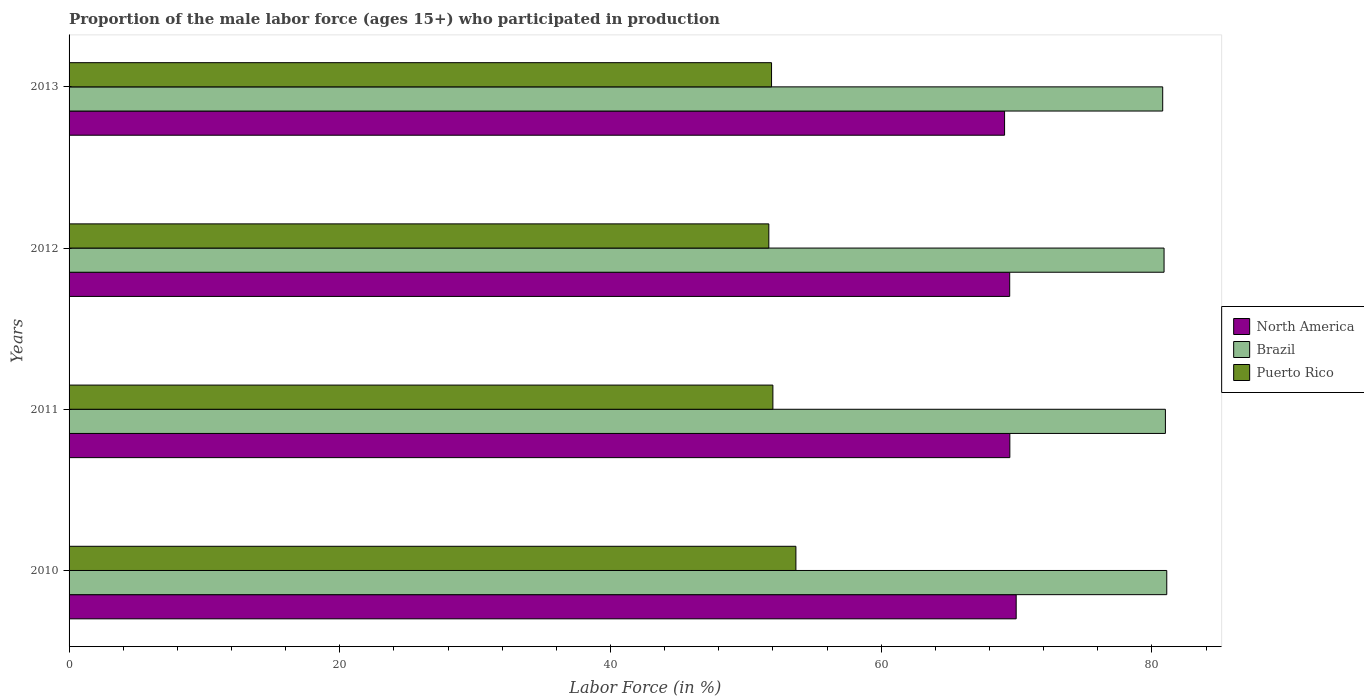How many different coloured bars are there?
Ensure brevity in your answer.  3. How many groups of bars are there?
Give a very brief answer. 4. How many bars are there on the 2nd tick from the bottom?
Your response must be concise. 3. What is the label of the 3rd group of bars from the top?
Provide a succinct answer. 2011. In how many cases, is the number of bars for a given year not equal to the number of legend labels?
Make the answer very short. 0. What is the proportion of the male labor force who participated in production in Puerto Rico in 2010?
Your response must be concise. 53.7. Across all years, what is the maximum proportion of the male labor force who participated in production in Brazil?
Your answer should be compact. 81.1. Across all years, what is the minimum proportion of the male labor force who participated in production in Brazil?
Offer a terse response. 80.8. In which year was the proportion of the male labor force who participated in production in Puerto Rico minimum?
Provide a short and direct response. 2012. What is the total proportion of the male labor force who participated in production in Brazil in the graph?
Make the answer very short. 323.8. What is the difference between the proportion of the male labor force who participated in production in Puerto Rico in 2010 and that in 2013?
Your response must be concise. 1.8. What is the difference between the proportion of the male labor force who participated in production in North America in 2010 and the proportion of the male labor force who participated in production in Puerto Rico in 2011?
Provide a succinct answer. 17.98. What is the average proportion of the male labor force who participated in production in Puerto Rico per year?
Provide a short and direct response. 52.33. In the year 2010, what is the difference between the proportion of the male labor force who participated in production in Puerto Rico and proportion of the male labor force who participated in production in Brazil?
Provide a succinct answer. -27.4. What is the ratio of the proportion of the male labor force who participated in production in Brazil in 2010 to that in 2011?
Ensure brevity in your answer.  1. Is the proportion of the male labor force who participated in production in Brazil in 2011 less than that in 2013?
Offer a very short reply. No. Is the difference between the proportion of the male labor force who participated in production in Puerto Rico in 2011 and 2013 greater than the difference between the proportion of the male labor force who participated in production in Brazil in 2011 and 2013?
Offer a very short reply. No. What is the difference between the highest and the second highest proportion of the male labor force who participated in production in Puerto Rico?
Keep it short and to the point. 1.7. What is the difference between the highest and the lowest proportion of the male labor force who participated in production in Brazil?
Your answer should be very brief. 0.3. Is the sum of the proportion of the male labor force who participated in production in Brazil in 2010 and 2012 greater than the maximum proportion of the male labor force who participated in production in North America across all years?
Provide a succinct answer. Yes. What does the 3rd bar from the top in 2012 represents?
Keep it short and to the point. North America. What does the 1st bar from the bottom in 2013 represents?
Give a very brief answer. North America. How many bars are there?
Your answer should be compact. 12. How many years are there in the graph?
Give a very brief answer. 4. What is the difference between two consecutive major ticks on the X-axis?
Provide a short and direct response. 20. Does the graph contain any zero values?
Make the answer very short. No. Where does the legend appear in the graph?
Ensure brevity in your answer.  Center right. How many legend labels are there?
Keep it short and to the point. 3. How are the legend labels stacked?
Ensure brevity in your answer.  Vertical. What is the title of the graph?
Keep it short and to the point. Proportion of the male labor force (ages 15+) who participated in production. What is the label or title of the X-axis?
Make the answer very short. Labor Force (in %). What is the label or title of the Y-axis?
Your answer should be compact. Years. What is the Labor Force (in %) of North America in 2010?
Offer a very short reply. 69.98. What is the Labor Force (in %) in Brazil in 2010?
Make the answer very short. 81.1. What is the Labor Force (in %) of Puerto Rico in 2010?
Keep it short and to the point. 53.7. What is the Labor Force (in %) of North America in 2011?
Your answer should be compact. 69.51. What is the Labor Force (in %) of Brazil in 2011?
Give a very brief answer. 81. What is the Labor Force (in %) in Puerto Rico in 2011?
Give a very brief answer. 52. What is the Labor Force (in %) in North America in 2012?
Your answer should be very brief. 69.5. What is the Labor Force (in %) in Brazil in 2012?
Your answer should be very brief. 80.9. What is the Labor Force (in %) in Puerto Rico in 2012?
Ensure brevity in your answer.  51.7. What is the Labor Force (in %) in North America in 2013?
Your answer should be very brief. 69.12. What is the Labor Force (in %) of Brazil in 2013?
Make the answer very short. 80.8. What is the Labor Force (in %) of Puerto Rico in 2013?
Offer a very short reply. 51.9. Across all years, what is the maximum Labor Force (in %) of North America?
Provide a short and direct response. 69.98. Across all years, what is the maximum Labor Force (in %) of Brazil?
Ensure brevity in your answer.  81.1. Across all years, what is the maximum Labor Force (in %) of Puerto Rico?
Ensure brevity in your answer.  53.7. Across all years, what is the minimum Labor Force (in %) in North America?
Give a very brief answer. 69.12. Across all years, what is the minimum Labor Force (in %) of Brazil?
Your answer should be compact. 80.8. Across all years, what is the minimum Labor Force (in %) in Puerto Rico?
Ensure brevity in your answer.  51.7. What is the total Labor Force (in %) in North America in the graph?
Make the answer very short. 278.1. What is the total Labor Force (in %) in Brazil in the graph?
Your response must be concise. 323.8. What is the total Labor Force (in %) of Puerto Rico in the graph?
Offer a very short reply. 209.3. What is the difference between the Labor Force (in %) of North America in 2010 and that in 2011?
Keep it short and to the point. 0.47. What is the difference between the Labor Force (in %) in Puerto Rico in 2010 and that in 2011?
Keep it short and to the point. 1.7. What is the difference between the Labor Force (in %) in North America in 2010 and that in 2012?
Your response must be concise. 0.48. What is the difference between the Labor Force (in %) of Brazil in 2010 and that in 2012?
Offer a very short reply. 0.2. What is the difference between the Labor Force (in %) in Puerto Rico in 2010 and that in 2012?
Your answer should be very brief. 2. What is the difference between the Labor Force (in %) of North America in 2010 and that in 2013?
Provide a succinct answer. 0.86. What is the difference between the Labor Force (in %) in North America in 2011 and that in 2012?
Your response must be concise. 0.01. What is the difference between the Labor Force (in %) of Brazil in 2011 and that in 2012?
Offer a very short reply. 0.1. What is the difference between the Labor Force (in %) of Puerto Rico in 2011 and that in 2012?
Provide a succinct answer. 0.3. What is the difference between the Labor Force (in %) in North America in 2011 and that in 2013?
Provide a succinct answer. 0.39. What is the difference between the Labor Force (in %) in North America in 2012 and that in 2013?
Make the answer very short. 0.38. What is the difference between the Labor Force (in %) of Brazil in 2012 and that in 2013?
Your response must be concise. 0.1. What is the difference between the Labor Force (in %) of Puerto Rico in 2012 and that in 2013?
Provide a succinct answer. -0.2. What is the difference between the Labor Force (in %) of North America in 2010 and the Labor Force (in %) of Brazil in 2011?
Give a very brief answer. -11.02. What is the difference between the Labor Force (in %) of North America in 2010 and the Labor Force (in %) of Puerto Rico in 2011?
Make the answer very short. 17.98. What is the difference between the Labor Force (in %) of Brazil in 2010 and the Labor Force (in %) of Puerto Rico in 2011?
Keep it short and to the point. 29.1. What is the difference between the Labor Force (in %) in North America in 2010 and the Labor Force (in %) in Brazil in 2012?
Ensure brevity in your answer.  -10.92. What is the difference between the Labor Force (in %) in North America in 2010 and the Labor Force (in %) in Puerto Rico in 2012?
Make the answer very short. 18.28. What is the difference between the Labor Force (in %) of Brazil in 2010 and the Labor Force (in %) of Puerto Rico in 2012?
Offer a terse response. 29.4. What is the difference between the Labor Force (in %) of North America in 2010 and the Labor Force (in %) of Brazil in 2013?
Offer a very short reply. -10.82. What is the difference between the Labor Force (in %) in North America in 2010 and the Labor Force (in %) in Puerto Rico in 2013?
Give a very brief answer. 18.08. What is the difference between the Labor Force (in %) in Brazil in 2010 and the Labor Force (in %) in Puerto Rico in 2013?
Give a very brief answer. 29.2. What is the difference between the Labor Force (in %) in North America in 2011 and the Labor Force (in %) in Brazil in 2012?
Provide a succinct answer. -11.39. What is the difference between the Labor Force (in %) in North America in 2011 and the Labor Force (in %) in Puerto Rico in 2012?
Your answer should be compact. 17.81. What is the difference between the Labor Force (in %) in Brazil in 2011 and the Labor Force (in %) in Puerto Rico in 2012?
Provide a succinct answer. 29.3. What is the difference between the Labor Force (in %) of North America in 2011 and the Labor Force (in %) of Brazil in 2013?
Provide a succinct answer. -11.29. What is the difference between the Labor Force (in %) in North America in 2011 and the Labor Force (in %) in Puerto Rico in 2013?
Give a very brief answer. 17.61. What is the difference between the Labor Force (in %) in Brazil in 2011 and the Labor Force (in %) in Puerto Rico in 2013?
Your answer should be very brief. 29.1. What is the difference between the Labor Force (in %) of North America in 2012 and the Labor Force (in %) of Brazil in 2013?
Provide a succinct answer. -11.3. What is the difference between the Labor Force (in %) of North America in 2012 and the Labor Force (in %) of Puerto Rico in 2013?
Your answer should be very brief. 17.6. What is the difference between the Labor Force (in %) in Brazil in 2012 and the Labor Force (in %) in Puerto Rico in 2013?
Keep it short and to the point. 29. What is the average Labor Force (in %) of North America per year?
Give a very brief answer. 69.52. What is the average Labor Force (in %) in Brazil per year?
Provide a short and direct response. 80.95. What is the average Labor Force (in %) in Puerto Rico per year?
Offer a very short reply. 52.33. In the year 2010, what is the difference between the Labor Force (in %) in North America and Labor Force (in %) in Brazil?
Make the answer very short. -11.12. In the year 2010, what is the difference between the Labor Force (in %) in North America and Labor Force (in %) in Puerto Rico?
Provide a succinct answer. 16.28. In the year 2010, what is the difference between the Labor Force (in %) in Brazil and Labor Force (in %) in Puerto Rico?
Provide a succinct answer. 27.4. In the year 2011, what is the difference between the Labor Force (in %) of North America and Labor Force (in %) of Brazil?
Offer a very short reply. -11.49. In the year 2011, what is the difference between the Labor Force (in %) in North America and Labor Force (in %) in Puerto Rico?
Make the answer very short. 17.51. In the year 2012, what is the difference between the Labor Force (in %) of North America and Labor Force (in %) of Brazil?
Give a very brief answer. -11.4. In the year 2012, what is the difference between the Labor Force (in %) in North America and Labor Force (in %) in Puerto Rico?
Provide a short and direct response. 17.8. In the year 2012, what is the difference between the Labor Force (in %) of Brazil and Labor Force (in %) of Puerto Rico?
Ensure brevity in your answer.  29.2. In the year 2013, what is the difference between the Labor Force (in %) of North America and Labor Force (in %) of Brazil?
Make the answer very short. -11.68. In the year 2013, what is the difference between the Labor Force (in %) of North America and Labor Force (in %) of Puerto Rico?
Your answer should be very brief. 17.22. In the year 2013, what is the difference between the Labor Force (in %) in Brazil and Labor Force (in %) in Puerto Rico?
Offer a very short reply. 28.9. What is the ratio of the Labor Force (in %) of North America in 2010 to that in 2011?
Your answer should be compact. 1.01. What is the ratio of the Labor Force (in %) of Puerto Rico in 2010 to that in 2011?
Give a very brief answer. 1.03. What is the ratio of the Labor Force (in %) of Puerto Rico in 2010 to that in 2012?
Keep it short and to the point. 1.04. What is the ratio of the Labor Force (in %) in North America in 2010 to that in 2013?
Make the answer very short. 1.01. What is the ratio of the Labor Force (in %) in Puerto Rico in 2010 to that in 2013?
Make the answer very short. 1.03. What is the ratio of the Labor Force (in %) of North America in 2011 to that in 2013?
Make the answer very short. 1.01. What is the ratio of the Labor Force (in %) of North America in 2012 to that in 2013?
Your response must be concise. 1.01. What is the ratio of the Labor Force (in %) of Brazil in 2012 to that in 2013?
Offer a very short reply. 1. What is the ratio of the Labor Force (in %) of Puerto Rico in 2012 to that in 2013?
Keep it short and to the point. 1. What is the difference between the highest and the second highest Labor Force (in %) in North America?
Offer a very short reply. 0.47. What is the difference between the highest and the second highest Labor Force (in %) in Puerto Rico?
Offer a terse response. 1.7. What is the difference between the highest and the lowest Labor Force (in %) of North America?
Offer a terse response. 0.86. What is the difference between the highest and the lowest Labor Force (in %) in Brazil?
Offer a very short reply. 0.3. What is the difference between the highest and the lowest Labor Force (in %) of Puerto Rico?
Keep it short and to the point. 2. 